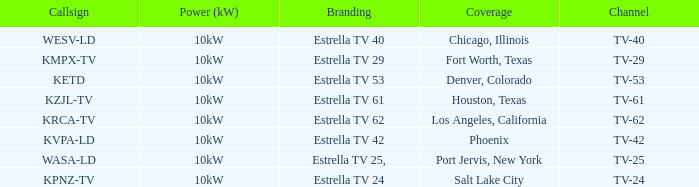Help me parse the entirety of this table. {'header': ['Callsign', 'Power (kW)', 'Branding', 'Coverage', 'Channel'], 'rows': [['WESV-LD', '10kW', 'Estrella TV 40', 'Chicago, Illinois', 'TV-40'], ['KMPX-TV', '10kW', 'Estrella TV 29', 'Fort Worth, Texas', 'TV-29'], ['KETD', '10kW', 'Estrella TV 53', 'Denver, Colorado', 'TV-53'], ['KZJL-TV', '10kW', 'Estrella TV 61', 'Houston, Texas', 'TV-61'], ['KRCA-TV', '10kW', 'Estrella TV 62', 'Los Angeles, California', 'TV-62'], ['KVPA-LD', '10kW', 'Estrella TV 42', 'Phoenix', 'TV-42'], ['WASA-LD', '10kW', 'Estrella TV 25,', 'Port Jervis, New York', 'TV-25'], ['KPNZ-TV', '10kW', 'Estrella TV 24', 'Salt Lake City', 'TV-24']]} List the power output for Phoenix.  10kW. 